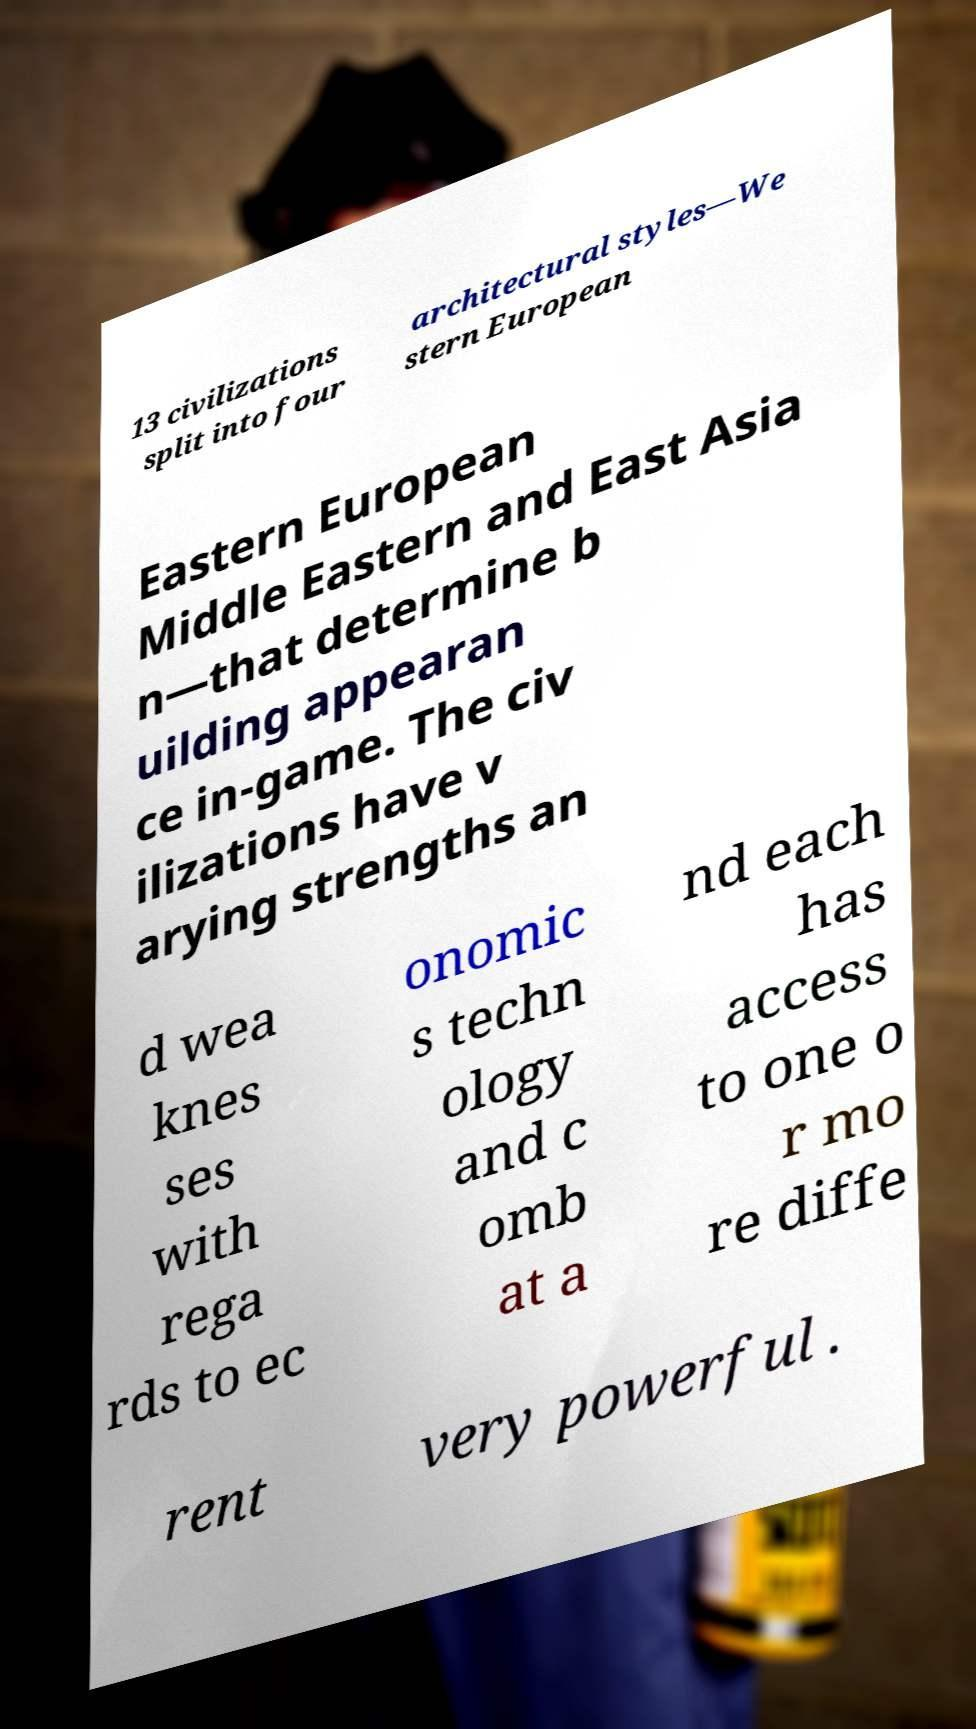Can you read and provide the text displayed in the image?This photo seems to have some interesting text. Can you extract and type it out for me? 13 civilizations split into four architectural styles—We stern European Eastern European Middle Eastern and East Asia n—that determine b uilding appearan ce in-game. The civ ilizations have v arying strengths an d wea knes ses with rega rds to ec onomic s techn ology and c omb at a nd each has access to one o r mo re diffe rent very powerful . 